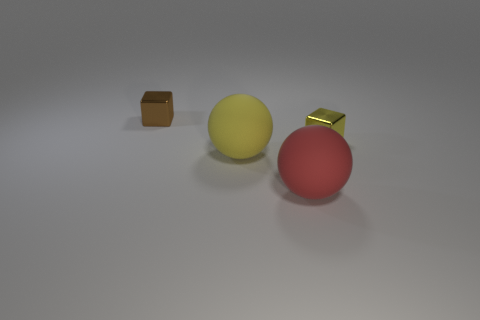Is the size of the red sphere the same as the yellow cube?
Give a very brief answer. No. What number of objects are both left of the yellow shiny cube and behind the large red thing?
Offer a terse response. 2. What number of brown objects are either tiny cubes or large rubber objects?
Ensure brevity in your answer.  1. What number of matte objects are yellow cubes or cubes?
Keep it short and to the point. 0. Are any red matte things visible?
Give a very brief answer. Yes. Does the small brown metal object have the same shape as the yellow matte thing?
Give a very brief answer. No. There is a shiny cube right of the metal thing that is on the left side of the large yellow matte ball; how many metal objects are behind it?
Offer a very short reply. 1. There is a object that is both behind the big yellow thing and to the right of the yellow sphere; what material is it made of?
Ensure brevity in your answer.  Metal. There is a object that is in front of the yellow metallic block and behind the red rubber sphere; what is its color?
Provide a short and direct response. Yellow. What is the shape of the small thing that is in front of the metallic cube that is behind the small cube that is right of the brown cube?
Offer a terse response. Cube. 